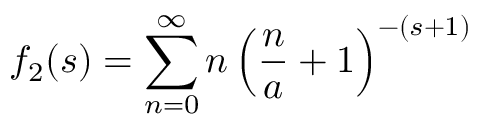<formula> <loc_0><loc_0><loc_500><loc_500>f _ { 2 } ( s ) = \sum _ { n = 0 } ^ { \infty } n \left ( \frac { n } { a } + 1 \right ) ^ { - ( s + 1 ) }</formula> 